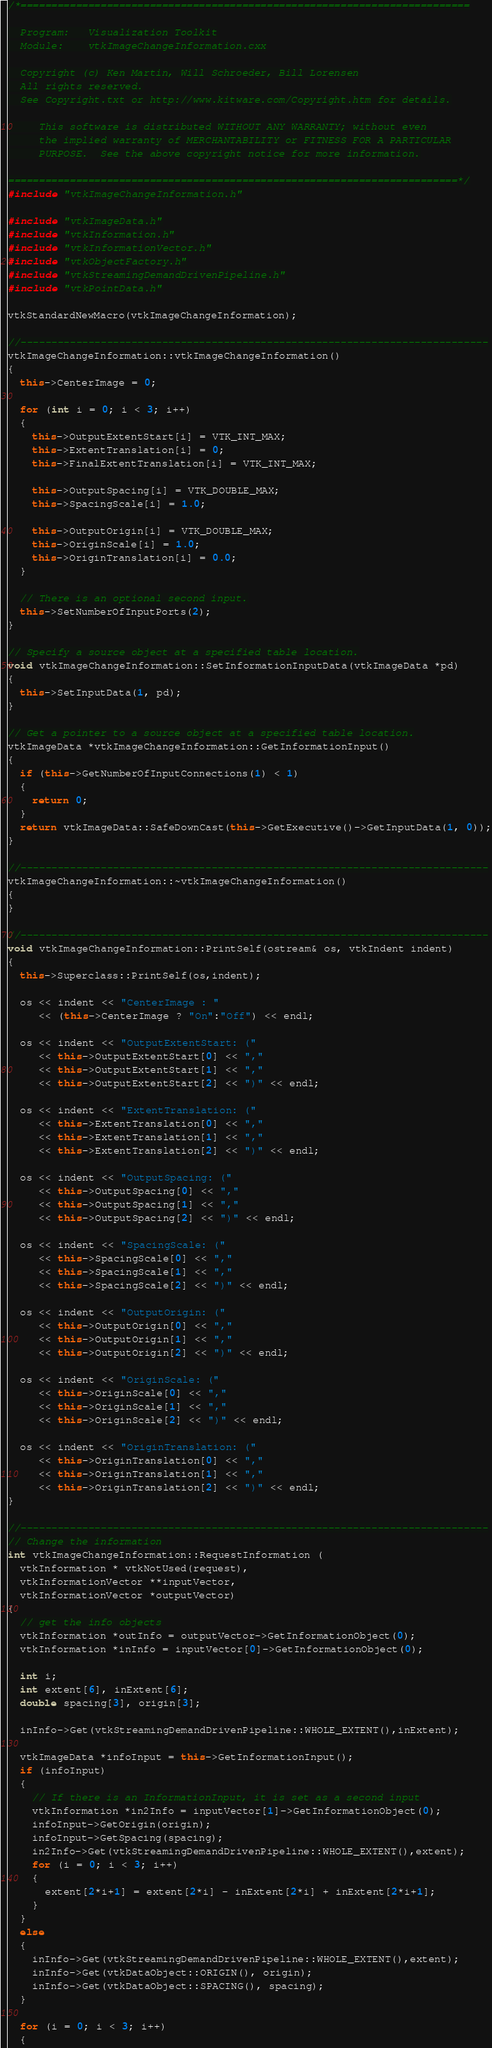<code> <loc_0><loc_0><loc_500><loc_500><_C++_>/*=========================================================================

  Program:   Visualization Toolkit
  Module:    vtkImageChangeInformation.cxx

  Copyright (c) Ken Martin, Will Schroeder, Bill Lorensen
  All rights reserved.
  See Copyright.txt or http://www.kitware.com/Copyright.htm for details.

     This software is distributed WITHOUT ANY WARRANTY; without even
     the implied warranty of MERCHANTABILITY or FITNESS FOR A PARTICULAR
     PURPOSE.  See the above copyright notice for more information.

=========================================================================*/
#include "vtkImageChangeInformation.h"

#include "vtkImageData.h"
#include "vtkInformation.h"
#include "vtkInformationVector.h"
#include "vtkObjectFactory.h"
#include "vtkStreamingDemandDrivenPipeline.h"
#include "vtkPointData.h"

vtkStandardNewMacro(vtkImageChangeInformation);

//----------------------------------------------------------------------------
vtkImageChangeInformation::vtkImageChangeInformation()
{
  this->CenterImage = 0;

  for (int i = 0; i < 3; i++)
  {
    this->OutputExtentStart[i] = VTK_INT_MAX;
    this->ExtentTranslation[i] = 0;
    this->FinalExtentTranslation[i] = VTK_INT_MAX;

    this->OutputSpacing[i] = VTK_DOUBLE_MAX;
    this->SpacingScale[i] = 1.0;

    this->OutputOrigin[i] = VTK_DOUBLE_MAX;
    this->OriginScale[i] = 1.0;
    this->OriginTranslation[i] = 0.0;
  }

  // There is an optional second input.
  this->SetNumberOfInputPorts(2);
}

// Specify a source object at a specified table location.
void vtkImageChangeInformation::SetInformationInputData(vtkImageData *pd)
{
  this->SetInputData(1, pd);
}

// Get a pointer to a source object at a specified table location.
vtkImageData *vtkImageChangeInformation::GetInformationInput()
{
  if (this->GetNumberOfInputConnections(1) < 1)
  {
    return 0;
  }
  return vtkImageData::SafeDownCast(this->GetExecutive()->GetInputData(1, 0));
}

//----------------------------------------------------------------------------
vtkImageChangeInformation::~vtkImageChangeInformation()
{
}

//----------------------------------------------------------------------------
void vtkImageChangeInformation::PrintSelf(ostream& os, vtkIndent indent)
{
  this->Superclass::PrintSelf(os,indent);

  os << indent << "CenterImage : "
     << (this->CenterImage ? "On":"Off") << endl;

  os << indent << "OutputExtentStart: ("
     << this->OutputExtentStart[0] << ","
     << this->OutputExtentStart[1] << ","
     << this->OutputExtentStart[2] << ")" << endl;

  os << indent << "ExtentTranslation: ("
     << this->ExtentTranslation[0] << ","
     << this->ExtentTranslation[1] << ","
     << this->ExtentTranslation[2] << ")" << endl;

  os << indent << "OutputSpacing: ("
     << this->OutputSpacing[0] << ","
     << this->OutputSpacing[1] << ","
     << this->OutputSpacing[2] << ")" << endl;

  os << indent << "SpacingScale: ("
     << this->SpacingScale[0] << ","
     << this->SpacingScale[1] << ","
     << this->SpacingScale[2] << ")" << endl;

  os << indent << "OutputOrigin: ("
     << this->OutputOrigin[0] << ","
     << this->OutputOrigin[1] << ","
     << this->OutputOrigin[2] << ")" << endl;

  os << indent << "OriginScale: ("
     << this->OriginScale[0] << ","
     << this->OriginScale[1] << ","
     << this->OriginScale[2] << ")" << endl;

  os << indent << "OriginTranslation: ("
     << this->OriginTranslation[0] << ","
     << this->OriginTranslation[1] << ","
     << this->OriginTranslation[2] << ")" << endl;
}

//----------------------------------------------------------------------------
// Change the information
int vtkImageChangeInformation::RequestInformation (
  vtkInformation * vtkNotUsed(request),
  vtkInformationVector **inputVector,
  vtkInformationVector *outputVector)
{
  // get the info objects
  vtkInformation *outInfo = outputVector->GetInformationObject(0);
  vtkInformation *inInfo = inputVector[0]->GetInformationObject(0);

  int i;
  int extent[6], inExtent[6];
  double spacing[3], origin[3];

  inInfo->Get(vtkStreamingDemandDrivenPipeline::WHOLE_EXTENT(),inExtent);

  vtkImageData *infoInput = this->GetInformationInput();
  if (infoInput)
  {
    // If there is an InformationInput, it is set as a second input
    vtkInformation *in2Info = inputVector[1]->GetInformationObject(0);
    infoInput->GetOrigin(origin);
    infoInput->GetSpacing(spacing);
    in2Info->Get(vtkStreamingDemandDrivenPipeline::WHOLE_EXTENT(),extent);
    for (i = 0; i < 3; i++)
    {
      extent[2*i+1] = extent[2*i] - inExtent[2*i] + inExtent[2*i+1];
    }
  }
  else
  {
    inInfo->Get(vtkStreamingDemandDrivenPipeline::WHOLE_EXTENT(),extent);
    inInfo->Get(vtkDataObject::ORIGIN(), origin);
    inInfo->Get(vtkDataObject::SPACING(), spacing);
  }

  for (i = 0; i < 3; i++)
  {</code> 